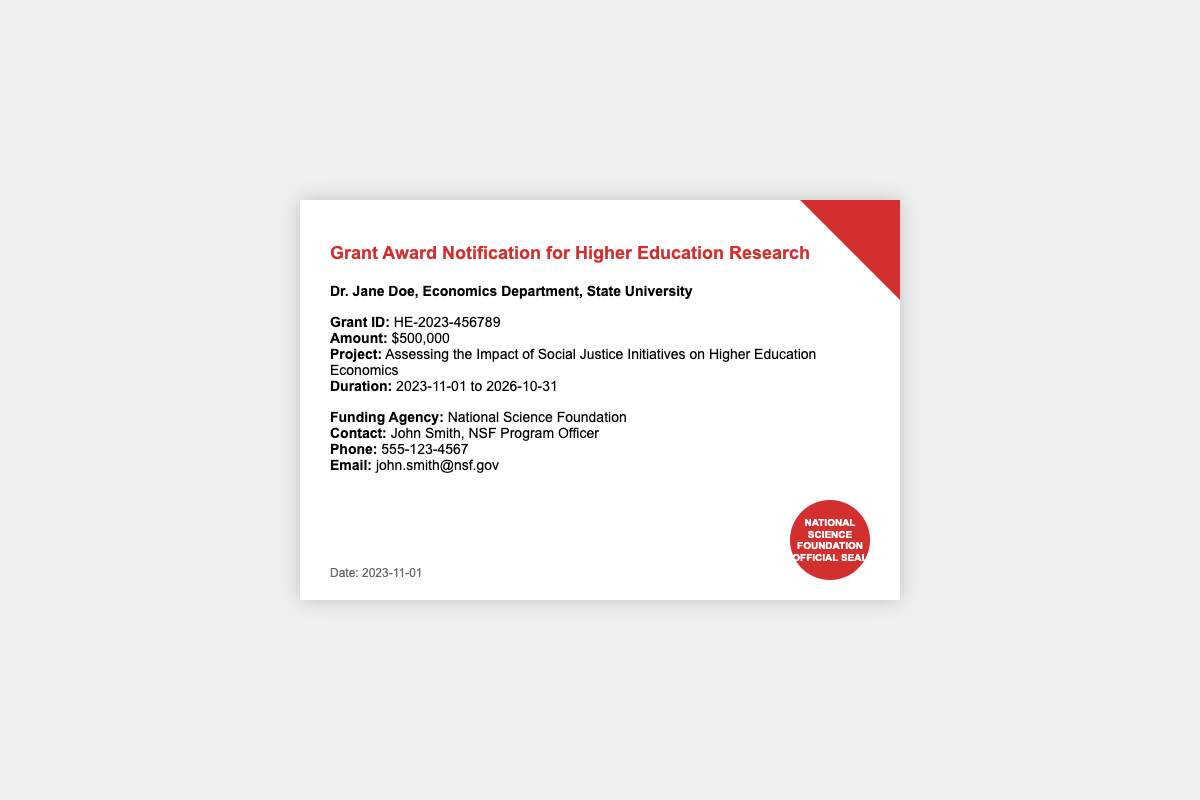what is the grant ID? The grant ID is explicitly mentioned in the document for identification purposes.
Answer: HE-2023-456789 what is the grant amount? The grant amount is clearly stated in the document under the funding details.
Answer: $500,000 who is the recipient of the grant? The recipient's name and affiliation are specified at the beginning of the document.
Answer: Dr. Jane Doe, Economics Department, State University what is the funding agency? The agency providing the funding is listed in the document.
Answer: National Science Foundation what is the project title? The title of the project is indicated in the details section of the document.
Answer: Assessing the Impact of Social Justice Initiatives on Higher Education Economics what is the project duration? The duration of the project is outlined in the document with specific dates.
Answer: 2023-11-01 to 2026-10-31 who is the contact at the funding agency? The document provides the contact person for further inquiries related to the grant.
Answer: John Smith, NSF Program Officer what is the phone number for the contact? The phone number for inquiries is provided in the contact details.
Answer: 555-123-4567 what type of document is this? The overall purpose and format of the document indicate its type.
Answer: Grant Award Notification 